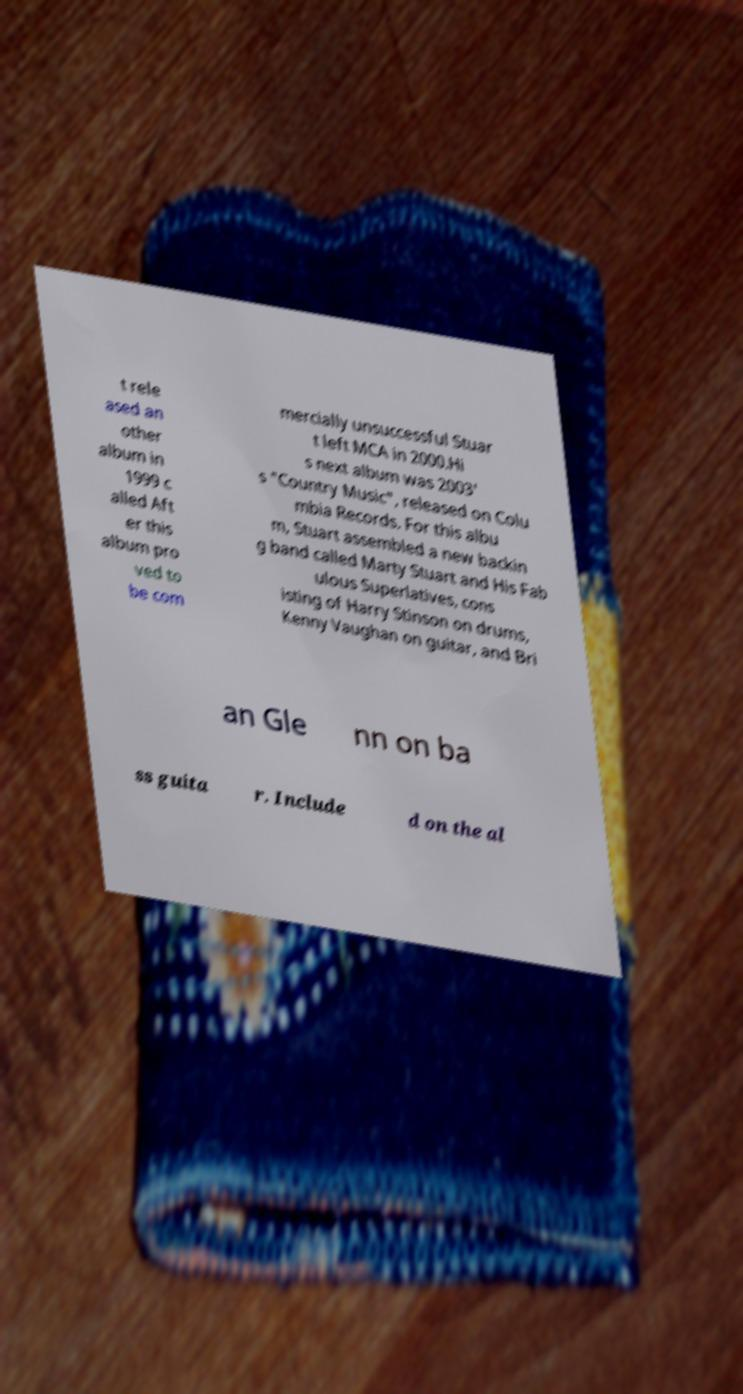Can you read and provide the text displayed in the image?This photo seems to have some interesting text. Can you extract and type it out for me? t rele ased an other album in 1999 c alled Aft er this album pro ved to be com mercially unsuccessful Stuar t left MCA in 2000.Hi s next album was 2003' s "Country Music", released on Colu mbia Records. For this albu m, Stuart assembled a new backin g band called Marty Stuart and His Fab ulous Superlatives, cons isting of Harry Stinson on drums, Kenny Vaughan on guitar, and Bri an Gle nn on ba ss guita r. Include d on the al 